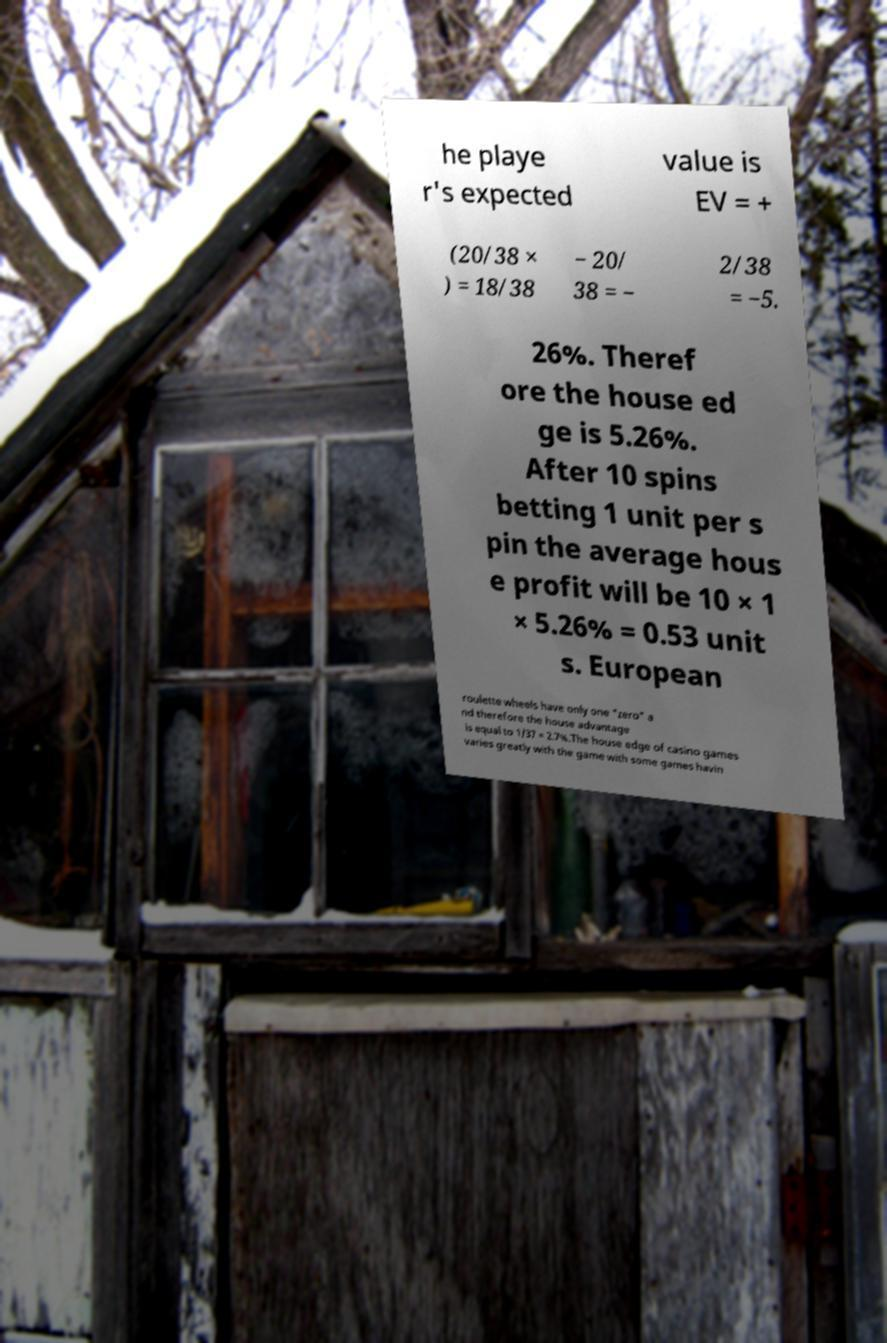Could you assist in decoding the text presented in this image and type it out clearly? he playe r's expected value is EV = + (20/38 × ) = 18/38 − 20/ 38 = − 2/38 = −5. 26%. Theref ore the house ed ge is 5.26%. After 10 spins betting 1 unit per s pin the average hous e profit will be 10 × 1 × 5.26% = 0.53 unit s. European roulette wheels have only one "zero" a nd therefore the house advantage is equal to 1/37 = 2.7%.The house edge of casino games varies greatly with the game with some games havin 